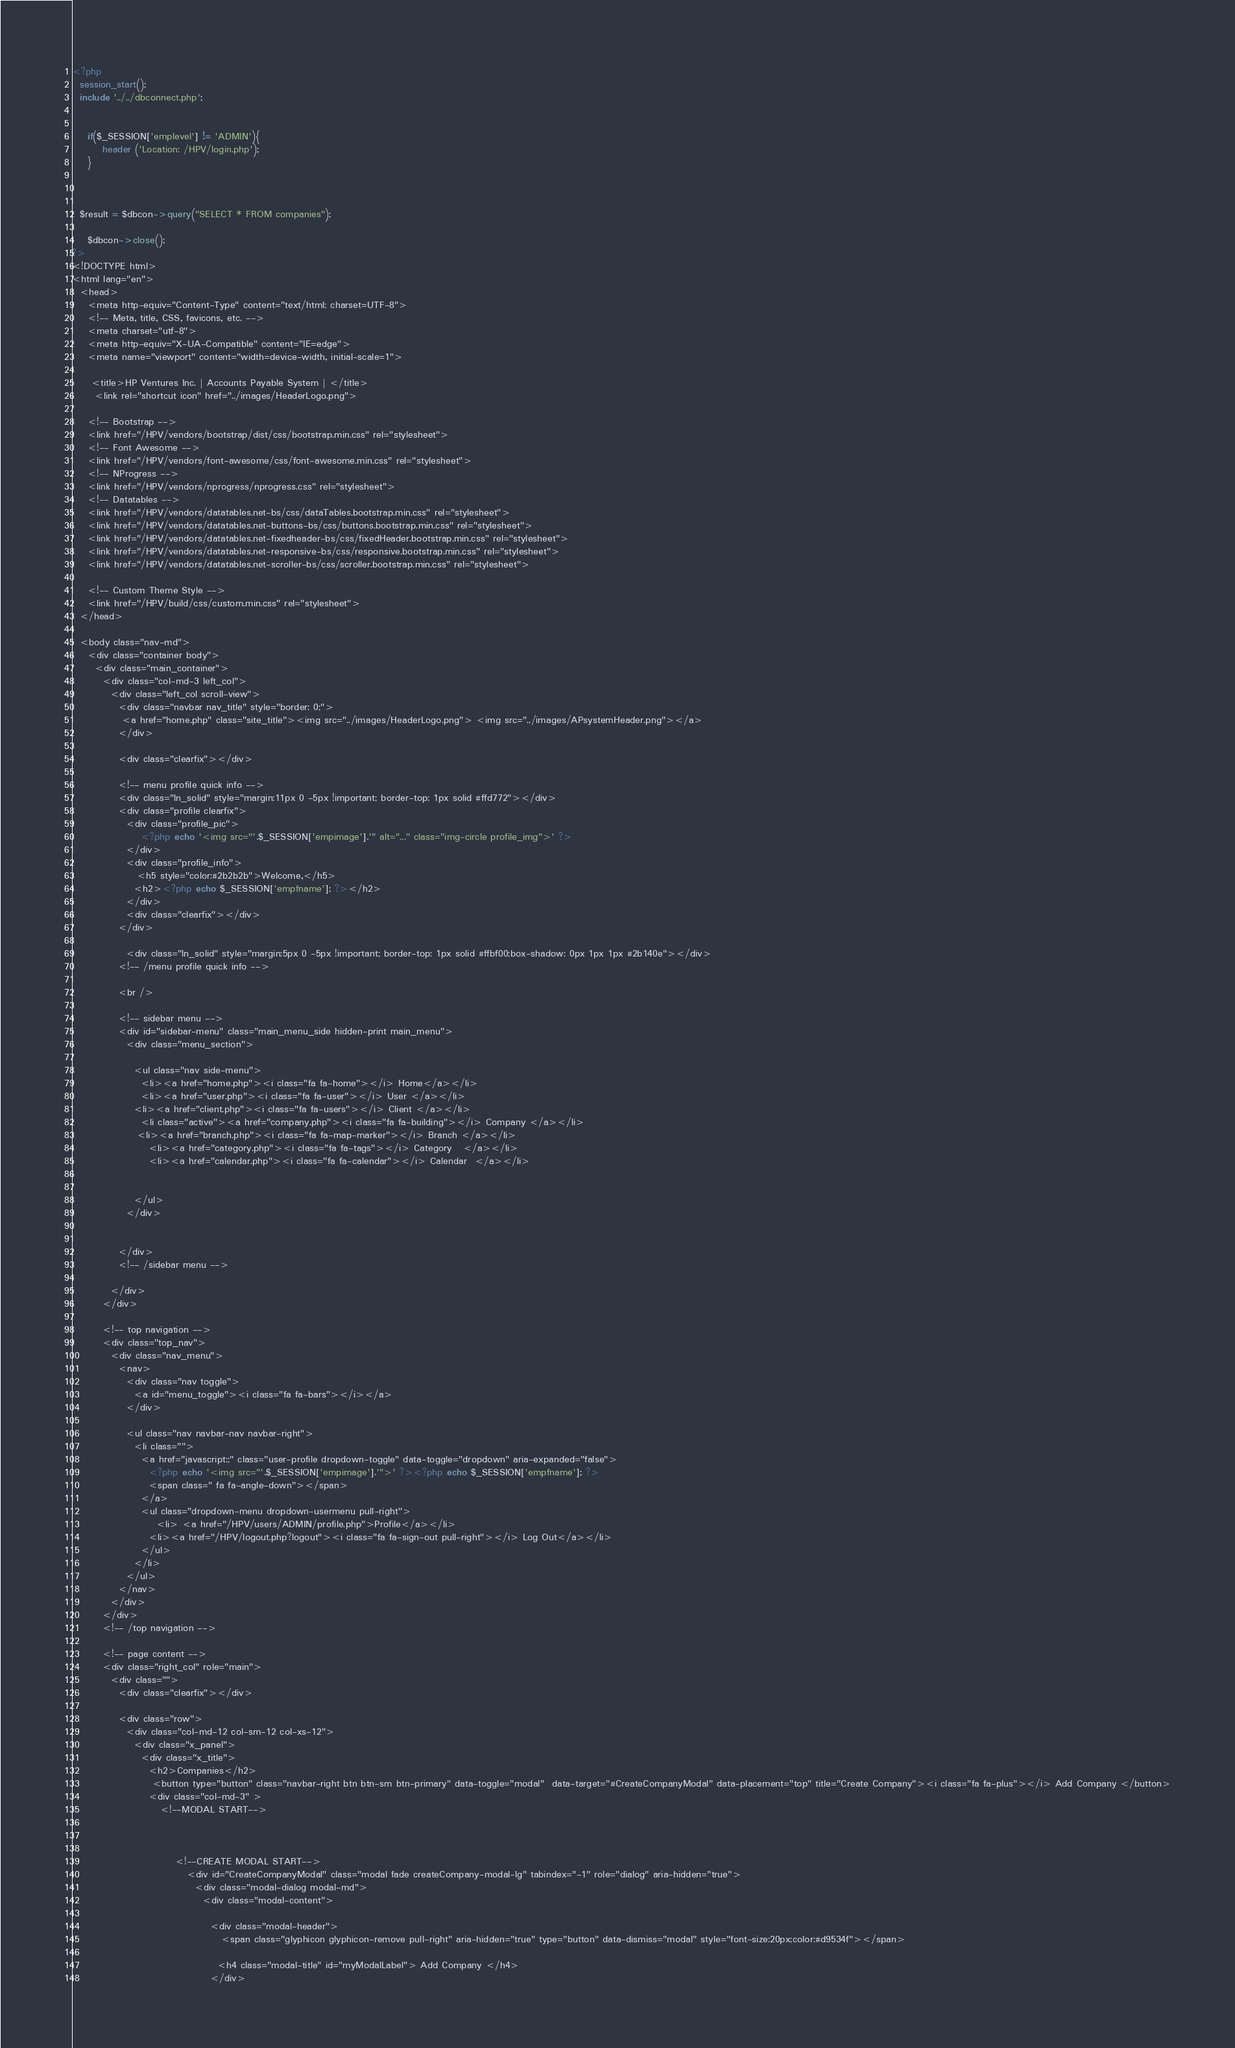Convert code to text. <code><loc_0><loc_0><loc_500><loc_500><_PHP_><?php 
  session_start();
  include '../../dbconnect.php';


    if($_SESSION['emplevel'] != 'ADMIN'){
        header ('Location: /HPV/login.php');
    }

 

  $result = $dbcon->query("SELECT * FROM companies");

    $dbcon->close();
?>
<!DOCTYPE html>
<html lang="en">
  <head>
    <meta http-equiv="Content-Type" content="text/html; charset=UTF-8">
    <!-- Meta, title, CSS, favicons, etc. -->
    <meta charset="utf-8">
    <meta http-equiv="X-UA-Compatible" content="IE=edge">
    <meta name="viewport" content="width=device-width, initial-scale=1">

     <title>HP Ventures Inc. | Accounts Payable System | </title>
      <link rel="shortcut icon" href="../images/HeaderLogo.png">

    <!-- Bootstrap -->
    <link href="/HPV/vendors/bootstrap/dist/css/bootstrap.min.css" rel="stylesheet">
    <!-- Font Awesome -->
    <link href="/HPV/vendors/font-awesome/css/font-awesome.min.css" rel="stylesheet">
    <!-- NProgress -->
    <link href="/HPV/vendors/nprogress/nprogress.css" rel="stylesheet">
    <!-- Datatables -->
    <link href="/HPV/vendors/datatables.net-bs/css/dataTables.bootstrap.min.css" rel="stylesheet">
    <link href="/HPV/vendors/datatables.net-buttons-bs/css/buttons.bootstrap.min.css" rel="stylesheet">
    <link href="/HPV/vendors/datatables.net-fixedheader-bs/css/fixedHeader.bootstrap.min.css" rel="stylesheet">
    <link href="/HPV/vendors/datatables.net-responsive-bs/css/responsive.bootstrap.min.css" rel="stylesheet">
    <link href="/HPV/vendors/datatables.net-scroller-bs/css/scroller.bootstrap.min.css" rel="stylesheet">

    <!-- Custom Theme Style -->
    <link href="/HPV/build/css/custom.min.css" rel="stylesheet">
  </head>

  <body class="nav-md">
    <div class="container body">
      <div class="main_container">
        <div class="col-md-3 left_col">
          <div class="left_col scroll-view">
            <div class="navbar nav_title" style="border: 0;">
             <a href="home.php" class="site_title"><img src="../images/HeaderLogo.png"> <img src="../images/APsystemHeader.png"></a>
            </div>

            <div class="clearfix"></div>

            <!-- menu profile quick info -->
            <div class="ln_solid" style="margin:11px 0 -5px !important; border-top: 1px solid #ffd772"></div>
            <div class="profile clearfix">
              <div class="profile_pic">
                  <?php echo '<img src="'.$_SESSION['empimage'].'" alt="..." class="img-circle profile_img">' ?>
              </div>
              <div class="profile_info">
                 <h5 style="color:#2b2b2b">Welcome,</h5>
                <h2><?php echo $_SESSION['empfname']; ?></h2>
              </div>
              <div class="clearfix"></div>
            </div>
           
              <div class="ln_solid" style="margin:5px 0 -5px !important; border-top: 1px solid #ffbf00;box-shadow: 0px 1px 1px #2b140e"></div>
            <!-- /menu profile quick info -->
            
            <br />
            
            <!-- sidebar menu -->
            <div id="sidebar-menu" class="main_menu_side hidden-print main_menu">
              <div class="menu_section">
               
                <ul class="nav side-menu">
                  <li><a href="home.php"><i class="fa fa-home"></i> Home</a></li> 
                  <li><a href="user.php"><i class="fa fa-user"></i> User </a></li>
                <li><a href="client.php"><i class="fa fa-users"></i> Client </a></li>     
                  <li class="active"><a href="company.php"><i class="fa fa-building"></i> Company </a></li>
                 <li><a href="branch.php"><i class="fa fa-map-marker"></i> Branch </a></li>
                    <li><a href="category.php"><i class="fa fa-tags"></i> Category   </a></li>
                    <li><a href="calendar.php"><i class="fa fa-calendar"></i> Calendar  </a></li>
                 
                  
                </ul>
              </div>
              

            </div>
            <!-- /sidebar menu -->
            
          </div>
        </div>

        <!-- top navigation -->
        <div class="top_nav">
          <div class="nav_menu">
            <nav>
              <div class="nav toggle">
                <a id="menu_toggle"><i class="fa fa-bars"></i></a>
              </div>

              <ul class="nav navbar-nav navbar-right">
                <li class="">
                  <a href="javascript:;" class="user-profile dropdown-toggle" data-toggle="dropdown" aria-expanded="false">
                    <?php echo '<img src="'.$_SESSION['empimage'].'">' ?><?php echo $_SESSION['empfname']; ?>
                    <span class=" fa fa-angle-down"></span>
                  </a>
                  <ul class="dropdown-menu dropdown-usermenu pull-right">
                      <li> <a href="/HPV/users/ADMIN/profile.php">Profile</a></li>
                    <li><a href="/HPV/logout.php?logout"><i class="fa fa-sign-out pull-right"></i> Log Out</a></li>
                  </ul>
                </li>
              </ul>
            </nav>
          </div>
        </div>
        <!-- /top navigation -->

        <!-- page content -->
        <div class="right_col" role="main">
          <div class="">
            <div class="clearfix"></div>

            <div class="row">
              <div class="col-md-12 col-sm-12 col-xs-12">
                <div class="x_panel">
                  <div class="x_title">
                    <h2>Companies</h2>
                     <button type="button" class="navbar-right btn btn-sm btn-primary" data-toggle="modal"  data-target="#CreateCompanyModal" data-placement="top" title="Create Company"><i class="fa fa-plus"></i> Add Company </button>
                    <div class="col-md-3" >
                       <!--MODAL START-->
                                       
                            
                            
                           <!--CREATE MODAL START-->
                              <div id="CreateCompanyModal" class="modal fade createCompany-modal-lg" tabindex="-1" role="dialog" aria-hidden="true">
                                <div class="modal-dialog modal-md">
                                  <div class="modal-content">

                                    <div class="modal-header">
                                       <span class="glyphicon glyphicon-remove pull-right" aria-hidden="true" type="button" data-dismiss="modal" style="font-size:20px;color:#d9534f"></span>
                                     
                                      <h4 class="modal-title" id="myModalLabel"> Add Company </h4>
                                    </div></code> 